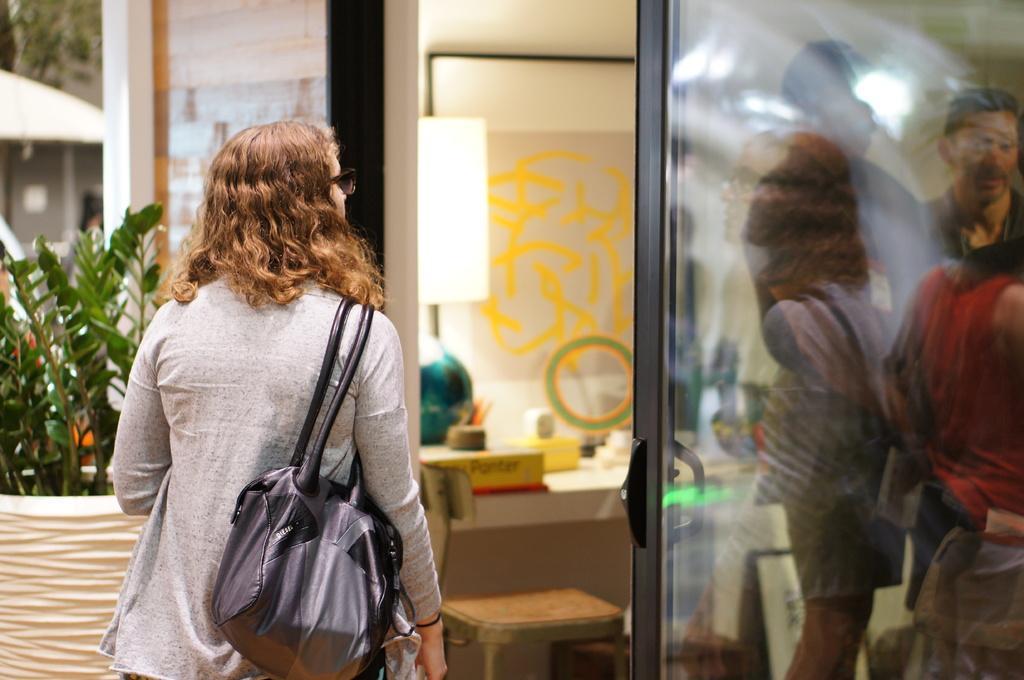In one or two sentences, can you explain what this image depicts? This person standing and wear bag. We can see chair,objects on the table,wall,plant,glass door,from this glass door we can see persons. 